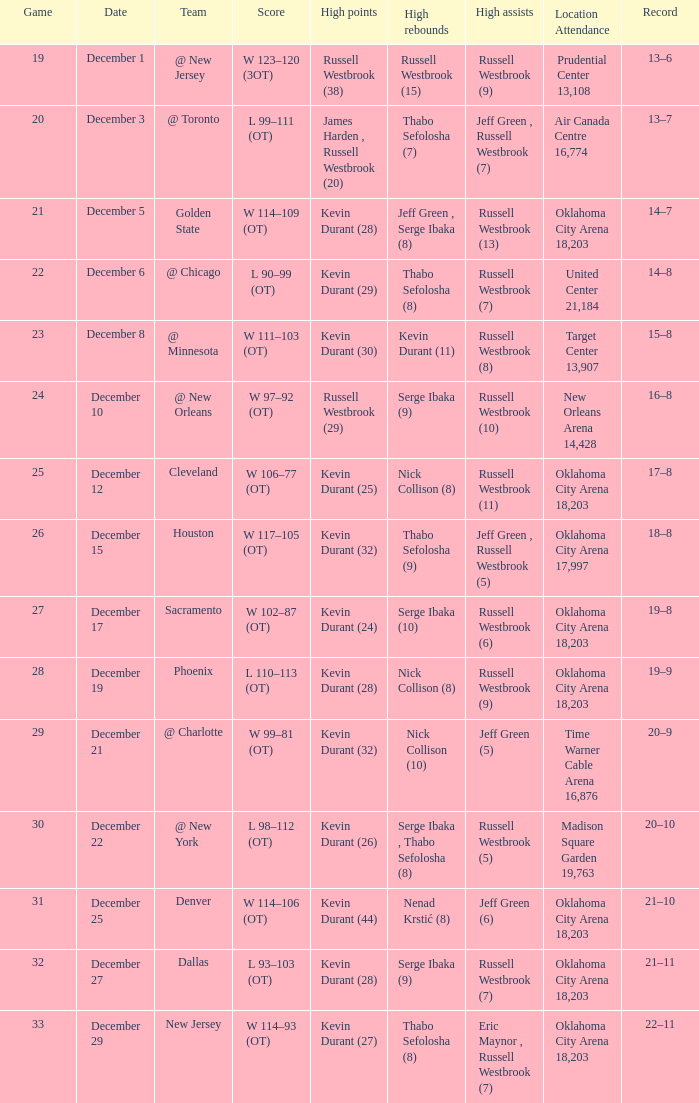On december 27, what was the record? 21–11. 